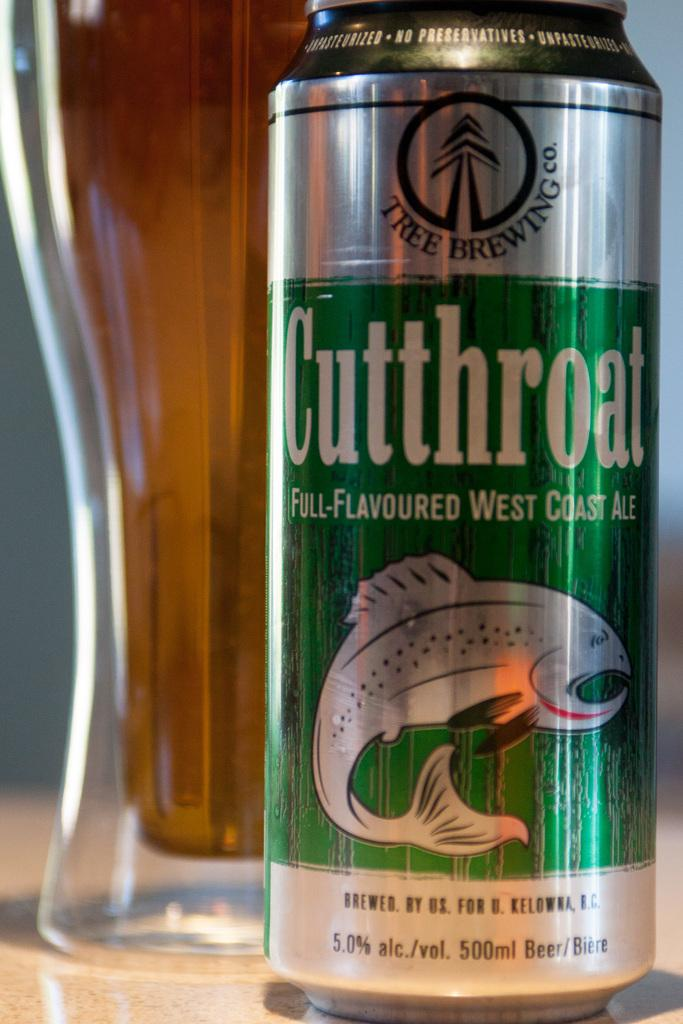Provide a one-sentence caption for the provided image. one can of beer that read cutthroat and behind the beer can is a glass full of beer. 